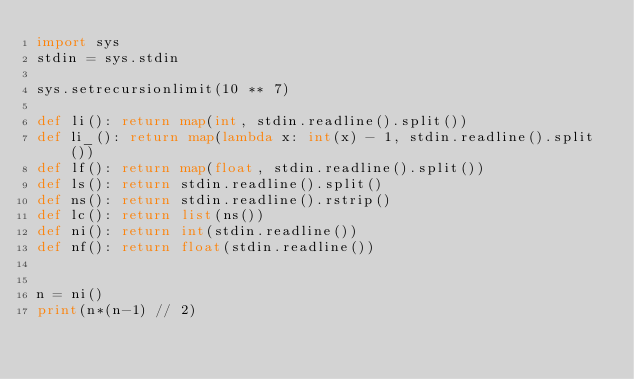<code> <loc_0><loc_0><loc_500><loc_500><_Python_>import sys
stdin = sys.stdin

sys.setrecursionlimit(10 ** 7)

def li(): return map(int, stdin.readline().split())
def li_(): return map(lambda x: int(x) - 1, stdin.readline().split())
def lf(): return map(float, stdin.readline().split())
def ls(): return stdin.readline().split()
def ns(): return stdin.readline().rstrip()
def lc(): return list(ns())
def ni(): return int(stdin.readline())
def nf(): return float(stdin.readline())


n = ni()
print(n*(n-1) // 2)</code> 